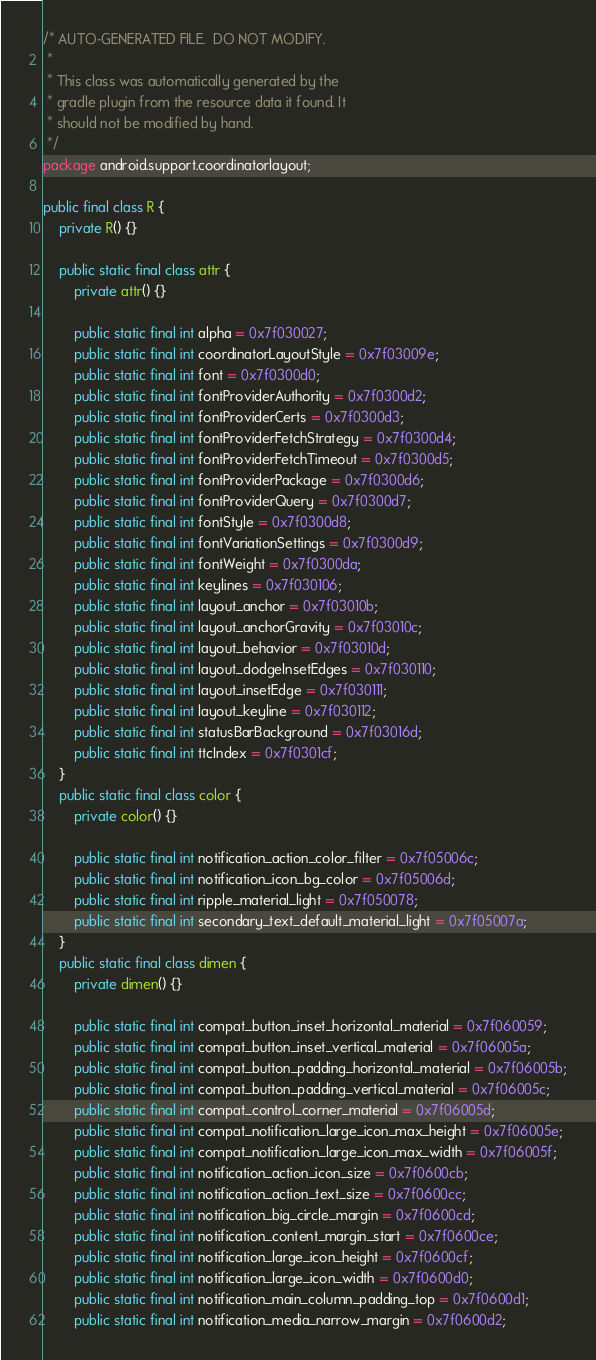Convert code to text. <code><loc_0><loc_0><loc_500><loc_500><_Java_>/* AUTO-GENERATED FILE.  DO NOT MODIFY.
 *
 * This class was automatically generated by the
 * gradle plugin from the resource data it found. It
 * should not be modified by hand.
 */
package android.support.coordinatorlayout;

public final class R {
    private R() {}

    public static final class attr {
        private attr() {}

        public static final int alpha = 0x7f030027;
        public static final int coordinatorLayoutStyle = 0x7f03009e;
        public static final int font = 0x7f0300d0;
        public static final int fontProviderAuthority = 0x7f0300d2;
        public static final int fontProviderCerts = 0x7f0300d3;
        public static final int fontProviderFetchStrategy = 0x7f0300d4;
        public static final int fontProviderFetchTimeout = 0x7f0300d5;
        public static final int fontProviderPackage = 0x7f0300d6;
        public static final int fontProviderQuery = 0x7f0300d7;
        public static final int fontStyle = 0x7f0300d8;
        public static final int fontVariationSettings = 0x7f0300d9;
        public static final int fontWeight = 0x7f0300da;
        public static final int keylines = 0x7f030106;
        public static final int layout_anchor = 0x7f03010b;
        public static final int layout_anchorGravity = 0x7f03010c;
        public static final int layout_behavior = 0x7f03010d;
        public static final int layout_dodgeInsetEdges = 0x7f030110;
        public static final int layout_insetEdge = 0x7f030111;
        public static final int layout_keyline = 0x7f030112;
        public static final int statusBarBackground = 0x7f03016d;
        public static final int ttcIndex = 0x7f0301cf;
    }
    public static final class color {
        private color() {}

        public static final int notification_action_color_filter = 0x7f05006c;
        public static final int notification_icon_bg_color = 0x7f05006d;
        public static final int ripple_material_light = 0x7f050078;
        public static final int secondary_text_default_material_light = 0x7f05007a;
    }
    public static final class dimen {
        private dimen() {}

        public static final int compat_button_inset_horizontal_material = 0x7f060059;
        public static final int compat_button_inset_vertical_material = 0x7f06005a;
        public static final int compat_button_padding_horizontal_material = 0x7f06005b;
        public static final int compat_button_padding_vertical_material = 0x7f06005c;
        public static final int compat_control_corner_material = 0x7f06005d;
        public static final int compat_notification_large_icon_max_height = 0x7f06005e;
        public static final int compat_notification_large_icon_max_width = 0x7f06005f;
        public static final int notification_action_icon_size = 0x7f0600cb;
        public static final int notification_action_text_size = 0x7f0600cc;
        public static final int notification_big_circle_margin = 0x7f0600cd;
        public static final int notification_content_margin_start = 0x7f0600ce;
        public static final int notification_large_icon_height = 0x7f0600cf;
        public static final int notification_large_icon_width = 0x7f0600d0;
        public static final int notification_main_column_padding_top = 0x7f0600d1;
        public static final int notification_media_narrow_margin = 0x7f0600d2;</code> 